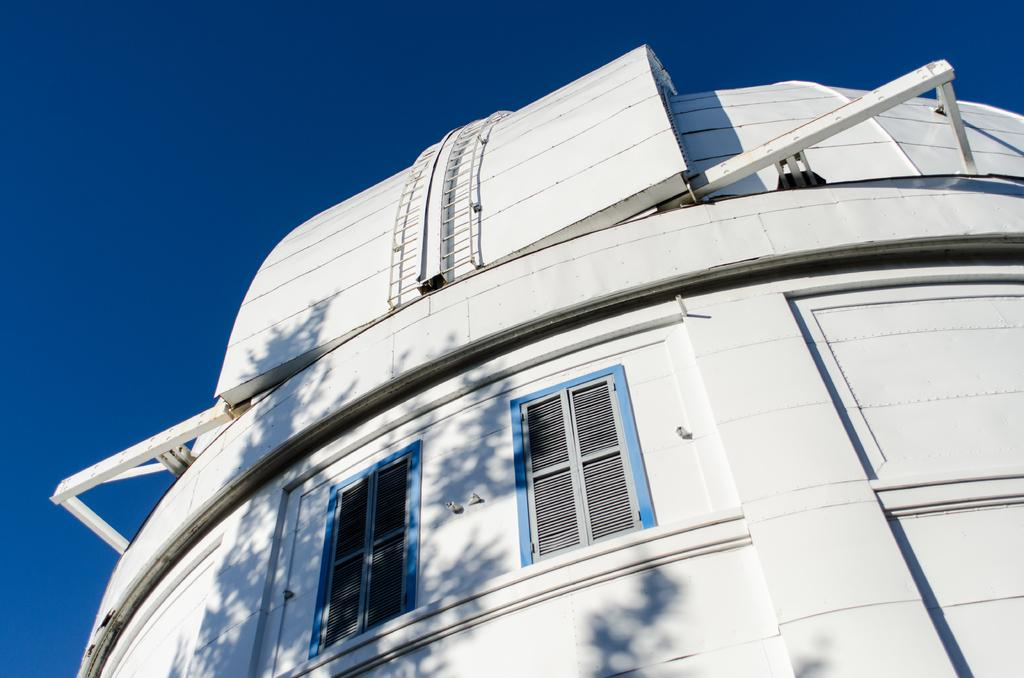What is the main subject of the picture? The main subject of the picture is a building. What specific features can be observed on the building? The building has windows. What type of bean is growing on the side of the building in the image? There is no bean plant visible on the side of the building in the image. 